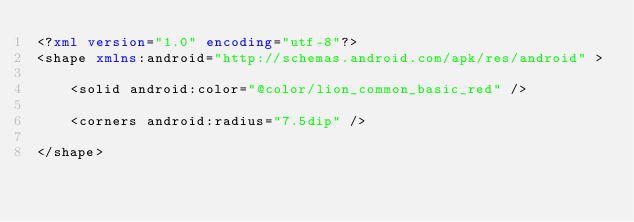Convert code to text. <code><loc_0><loc_0><loc_500><loc_500><_XML_><?xml version="1.0" encoding="utf-8"?>
<shape xmlns:android="http://schemas.android.com/apk/res/android" >

    <solid android:color="@color/lion_common_basic_red" />

    <corners android:radius="7.5dip" />

</shape></code> 